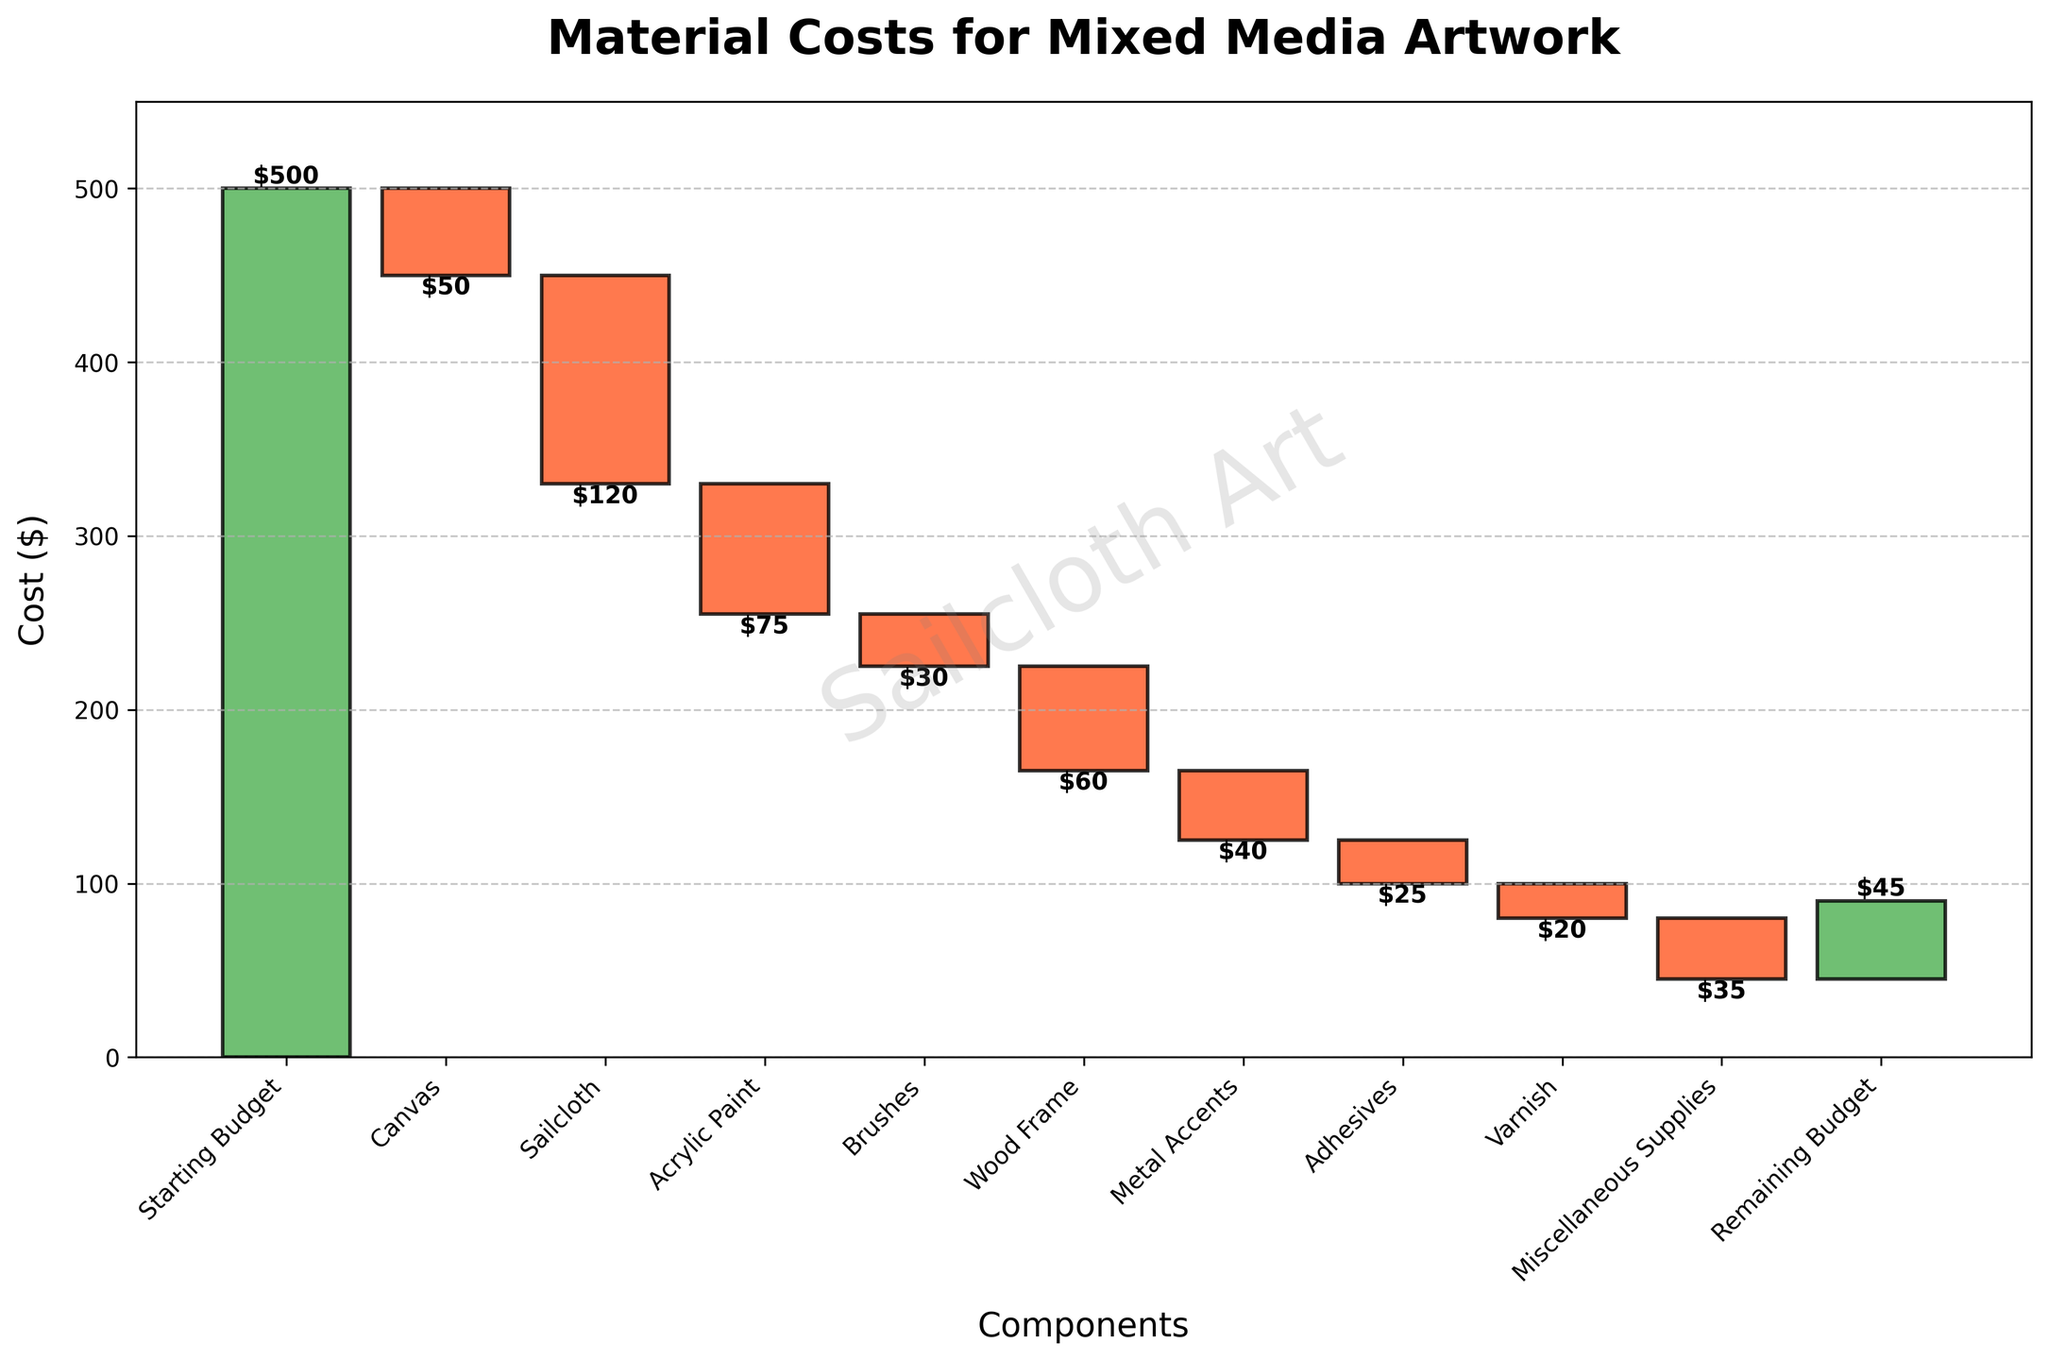What is the title of the chart? The title of the chart is usually displayed at the top and provides an overview of what the chart represents. In this case, it reads "Material Costs for Mixed Media Artwork".
Answer: Material Costs for Mixed Media Artwork How many components are listed in the chart? The components are listed along the x-axis and each component has a corresponding tick. By counting the ticks, you can determine the number of components.
Answer: 10 What category has the highest cost? To find the category with the highest cost, look for the longest red bar, which denotes a negative value representing cost. Refer to the labeled amounts for each category. Sailcloth has the highest cost at $120.
Answer: Sailcloth What is the remaining budget after all costs? The remaining budget is usually shown at the end, marked in green bars. It refers to the final value after all increments and decrements. The remaining budget is shown at the end of the chart and labeled $45.
Answer: $45 What are the colors associated with positive and negative values? Positive values, such as the starting and remaining budgets, are indicated by green bars. Negative values (costs) are shown in red bars. You can infer this from the length and placement of the bars relative to the starting budget.
Answer: Green for positive, Red for negative What's the total cost of Sailcloth and Acrylic Paint combined? To calculate the combined cost, identify the values for Sailcloth (-$120) and Acrylic Paint (-$75), and then add them together. -$120 + -$75 = -$195.
Answer: $195 Which component has the lowest cost? Find the smallest red bar, indicating the lowest cost. Both the Varnish and Adhesives categories have costs of $20 and $25 respectively, with Varnish being the lowest.
Answer: Varnish How does the cost of Wood Frame compare to Metal Accents? Identify the values for both categories (Wood Frame -$60, Metal Accents -$40), and compare their absolute values. The Wood Frame costs $20 more than Metal Accents.
Answer: Wood Frame is $20 more than Metal Accents How many components have costs less than $50? Review the bar values and count those with negative values less than $50. The categories are: Canvas (-$50), Brushes (-$30), Metal Accents (-$40), Adhesives (-$25), and Varnish (-$20).
Answer: 5 What's the cumulative cost before the Miscellaneous Supplies expense is added? To determine the cumulative cost before Miscellaneous Supplies, sum the costs of all previous components. Starting from the Starting Budget (500), deduct the listed costs sequentially: 500 - 50 - 120 - 75 - 30 - 60 - 40 - 25 - 20 = 80.
Answer: $80 